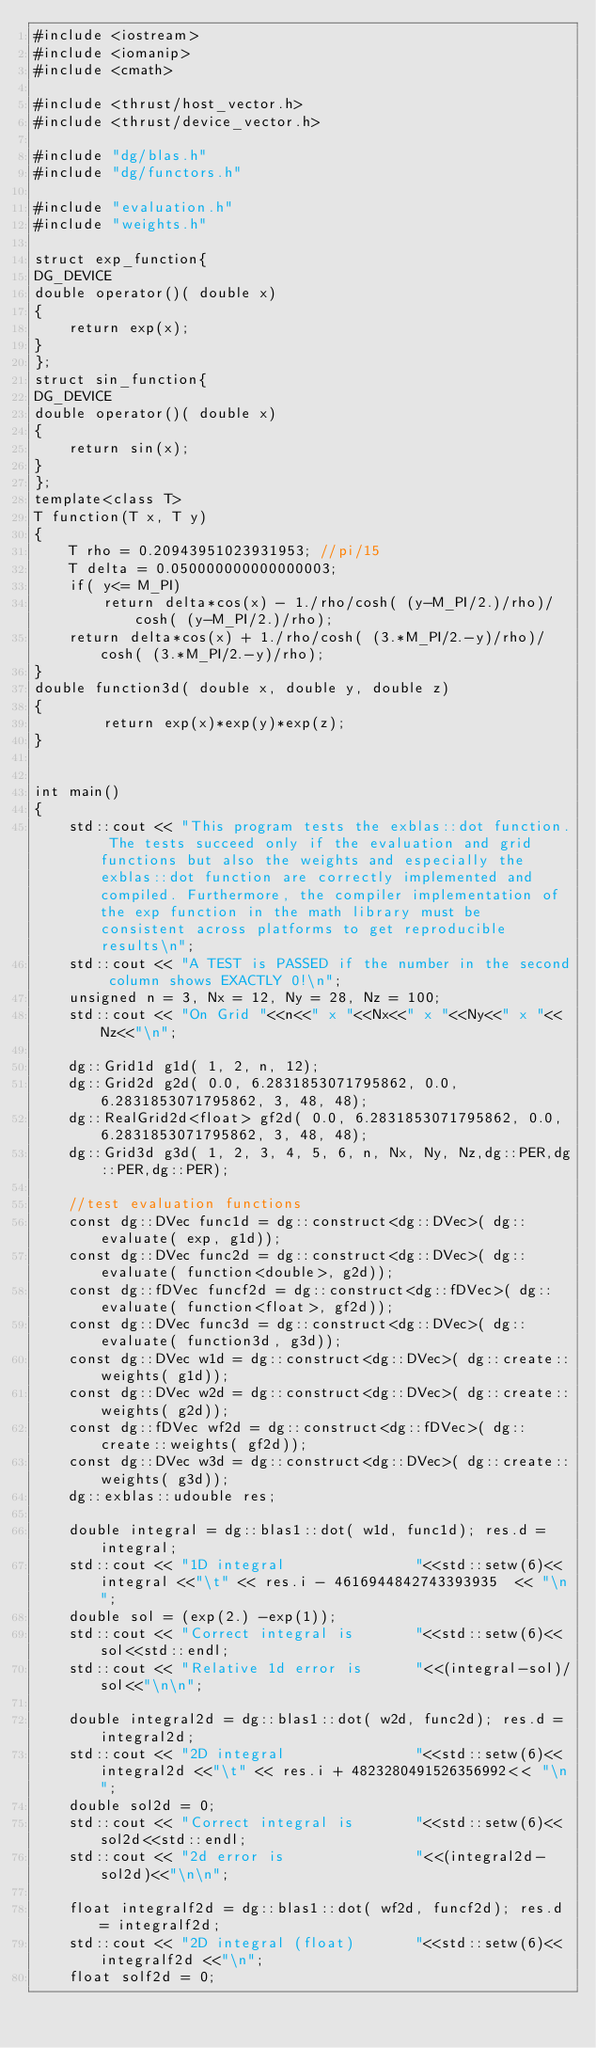Convert code to text. <code><loc_0><loc_0><loc_500><loc_500><_Cuda_>#include <iostream>
#include <iomanip>
#include <cmath>

#include <thrust/host_vector.h>
#include <thrust/device_vector.h>

#include "dg/blas.h"
#include "dg/functors.h"

#include "evaluation.h"
#include "weights.h"

struct exp_function{
DG_DEVICE
double operator()( double x)
{
    return exp(x);
}
};
struct sin_function{
DG_DEVICE
double operator()( double x)
{
    return sin(x);
}
};
template<class T>
T function(T x, T y)
{
    T rho = 0.20943951023931953; //pi/15
    T delta = 0.050000000000000003;
    if( y<= M_PI)
        return delta*cos(x) - 1./rho/cosh( (y-M_PI/2.)/rho)/cosh( (y-M_PI/2.)/rho);
    return delta*cos(x) + 1./rho/cosh( (3.*M_PI/2.-y)/rho)/cosh( (3.*M_PI/2.-y)/rho);
}
double function3d( double x, double y, double z)
{
        return exp(x)*exp(y)*exp(z);
}


int main()
{
    std::cout << "This program tests the exblas::dot function. The tests succeed only if the evaluation and grid functions but also the weights and especially the exblas::dot function are correctly implemented and compiled. Furthermore, the compiler implementation of the exp function in the math library must be consistent across platforms to get reproducible results\n";
    std::cout << "A TEST is PASSED if the number in the second column shows EXACTLY 0!\n";
    unsigned n = 3, Nx = 12, Ny = 28, Nz = 100;
    std::cout << "On Grid "<<n<<" x "<<Nx<<" x "<<Ny<<" x "<<Nz<<"\n";

    dg::Grid1d g1d( 1, 2, n, 12);
    dg::Grid2d g2d( 0.0, 6.2831853071795862, 0.0, 6.2831853071795862, 3, 48, 48);
    dg::RealGrid2d<float> gf2d( 0.0, 6.2831853071795862, 0.0, 6.2831853071795862, 3, 48, 48);
    dg::Grid3d g3d( 1, 2, 3, 4, 5, 6, n, Nx, Ny, Nz,dg::PER,dg::PER,dg::PER);

    //test evaluation functions
    const dg::DVec func1d = dg::construct<dg::DVec>( dg::evaluate( exp, g1d));
    const dg::DVec func2d = dg::construct<dg::DVec>( dg::evaluate( function<double>, g2d));
    const dg::fDVec funcf2d = dg::construct<dg::fDVec>( dg::evaluate( function<float>, gf2d));
    const dg::DVec func3d = dg::construct<dg::DVec>( dg::evaluate( function3d, g3d));
    const dg::DVec w1d = dg::construct<dg::DVec>( dg::create::weights( g1d));
    const dg::DVec w2d = dg::construct<dg::DVec>( dg::create::weights( g2d));
    const dg::fDVec wf2d = dg::construct<dg::fDVec>( dg::create::weights( gf2d));
    const dg::DVec w3d = dg::construct<dg::DVec>( dg::create::weights( g3d));
    dg::exblas::udouble res;

    double integral = dg::blas1::dot( w1d, func1d); res.d = integral;
    std::cout << "1D integral               "<<std::setw(6)<<integral <<"\t" << res.i - 4616944842743393935  << "\n";
    double sol = (exp(2.) -exp(1));
    std::cout << "Correct integral is       "<<std::setw(6)<<sol<<std::endl;
    std::cout << "Relative 1d error is      "<<(integral-sol)/sol<<"\n\n";

    double integral2d = dg::blas1::dot( w2d, func2d); res.d = integral2d;
    std::cout << "2D integral               "<<std::setw(6)<<integral2d <<"\t" << res.i + 4823280491526356992<< "\n";
    double sol2d = 0;
    std::cout << "Correct integral is       "<<std::setw(6)<<sol2d<<std::endl;
    std::cout << "2d error is               "<<(integral2d-sol2d)<<"\n\n";

    float integralf2d = dg::blas1::dot( wf2d, funcf2d); res.d = integralf2d;
    std::cout << "2D integral (float)       "<<std::setw(6)<<integralf2d <<"\n";
    float solf2d = 0;</code> 